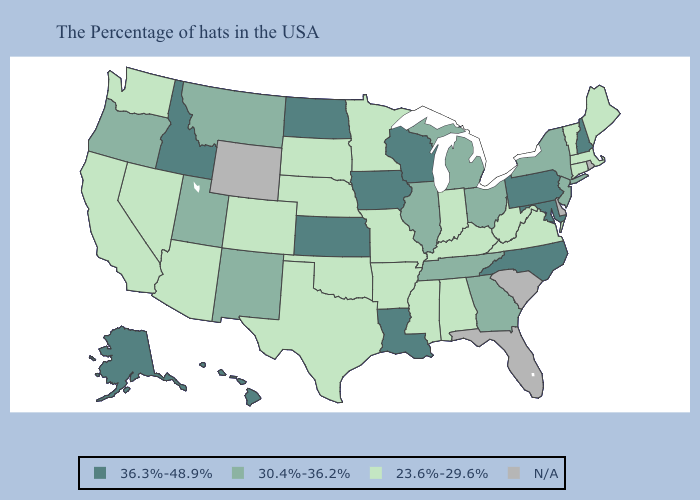Which states have the lowest value in the Northeast?
Be succinct. Maine, Massachusetts, Vermont, Connecticut. Does Ohio have the lowest value in the MidWest?
Write a very short answer. No. What is the value of Georgia?
Write a very short answer. 30.4%-36.2%. What is the value of Alaska?
Give a very brief answer. 36.3%-48.9%. Which states have the highest value in the USA?
Concise answer only. New Hampshire, Maryland, Pennsylvania, North Carolina, Wisconsin, Louisiana, Iowa, Kansas, North Dakota, Idaho, Alaska, Hawaii. Name the states that have a value in the range 36.3%-48.9%?
Keep it brief. New Hampshire, Maryland, Pennsylvania, North Carolina, Wisconsin, Louisiana, Iowa, Kansas, North Dakota, Idaho, Alaska, Hawaii. What is the lowest value in the Northeast?
Give a very brief answer. 23.6%-29.6%. Which states hav the highest value in the South?
Be succinct. Maryland, North Carolina, Louisiana. Which states hav the highest value in the MidWest?
Write a very short answer. Wisconsin, Iowa, Kansas, North Dakota. Does the first symbol in the legend represent the smallest category?
Concise answer only. No. What is the highest value in states that border Massachusetts?
Keep it brief. 36.3%-48.9%. What is the highest value in the West ?
Write a very short answer. 36.3%-48.9%. What is the highest value in the MidWest ?
Be succinct. 36.3%-48.9%. 